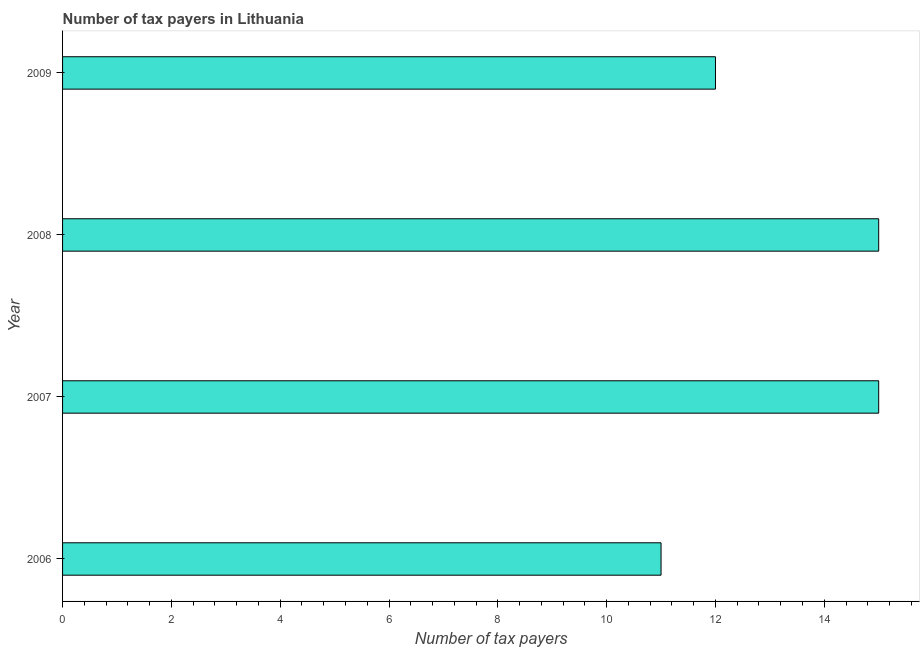Does the graph contain any zero values?
Your answer should be very brief. No. Does the graph contain grids?
Offer a terse response. No. What is the title of the graph?
Make the answer very short. Number of tax payers in Lithuania. What is the label or title of the X-axis?
Make the answer very short. Number of tax payers. What is the number of tax payers in 2007?
Offer a very short reply. 15. In which year was the number of tax payers maximum?
Make the answer very short. 2007. What is the average number of tax payers per year?
Provide a short and direct response. 13. What is the median number of tax payers?
Ensure brevity in your answer.  13.5. In how many years, is the number of tax payers greater than 13.6 ?
Offer a very short reply. 2. Do a majority of the years between 2006 and 2007 (inclusive) have number of tax payers greater than 1.2 ?
Your response must be concise. Yes. What is the ratio of the number of tax payers in 2006 to that in 2007?
Your answer should be very brief. 0.73. Is the number of tax payers in 2007 less than that in 2008?
Make the answer very short. No. Is the difference between the number of tax payers in 2006 and 2008 greater than the difference between any two years?
Give a very brief answer. Yes. How many bars are there?
Your answer should be very brief. 4. How many years are there in the graph?
Your response must be concise. 4. What is the Number of tax payers in 2006?
Offer a very short reply. 11. What is the difference between the Number of tax payers in 2006 and 2007?
Ensure brevity in your answer.  -4. What is the difference between the Number of tax payers in 2006 and 2009?
Keep it short and to the point. -1. What is the difference between the Number of tax payers in 2007 and 2008?
Provide a succinct answer. 0. What is the difference between the Number of tax payers in 2007 and 2009?
Keep it short and to the point. 3. What is the difference between the Number of tax payers in 2008 and 2009?
Give a very brief answer. 3. What is the ratio of the Number of tax payers in 2006 to that in 2007?
Give a very brief answer. 0.73. What is the ratio of the Number of tax payers in 2006 to that in 2008?
Ensure brevity in your answer.  0.73. What is the ratio of the Number of tax payers in 2006 to that in 2009?
Your answer should be very brief. 0.92. What is the ratio of the Number of tax payers in 2007 to that in 2008?
Keep it short and to the point. 1. What is the ratio of the Number of tax payers in 2007 to that in 2009?
Provide a short and direct response. 1.25. 